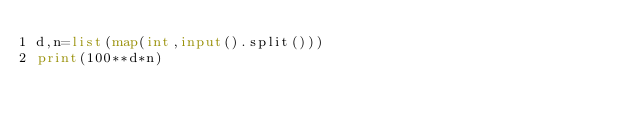<code> <loc_0><loc_0><loc_500><loc_500><_Python_>d,n=list(map(int,input().split()))
print(100**d*n)</code> 